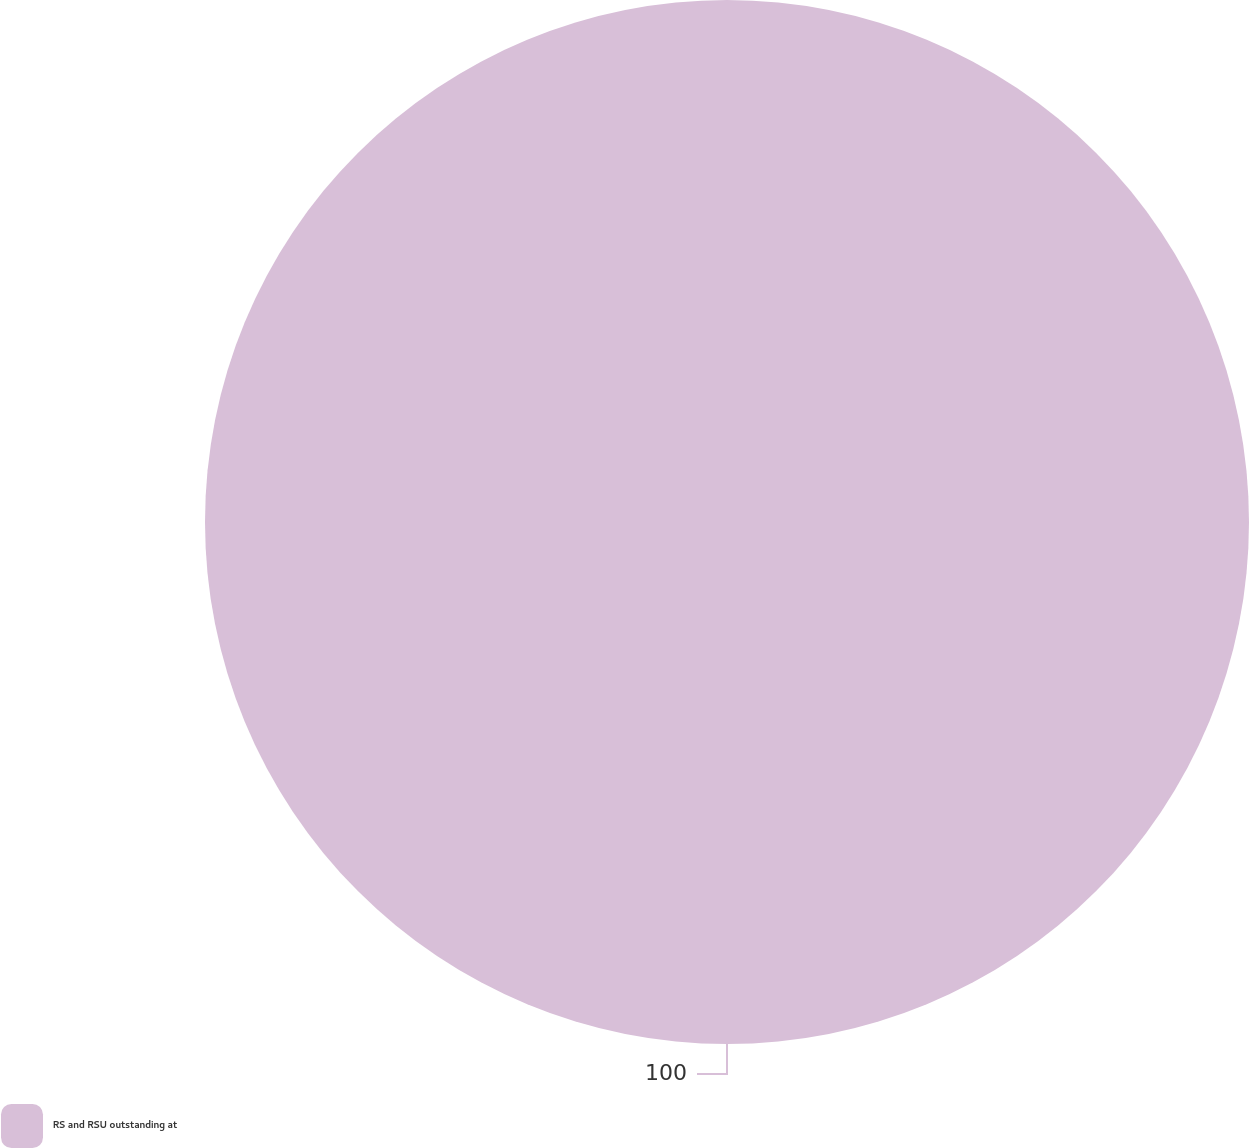<chart> <loc_0><loc_0><loc_500><loc_500><pie_chart><fcel>RS and RSU outstanding at<nl><fcel>100.0%<nl></chart> 